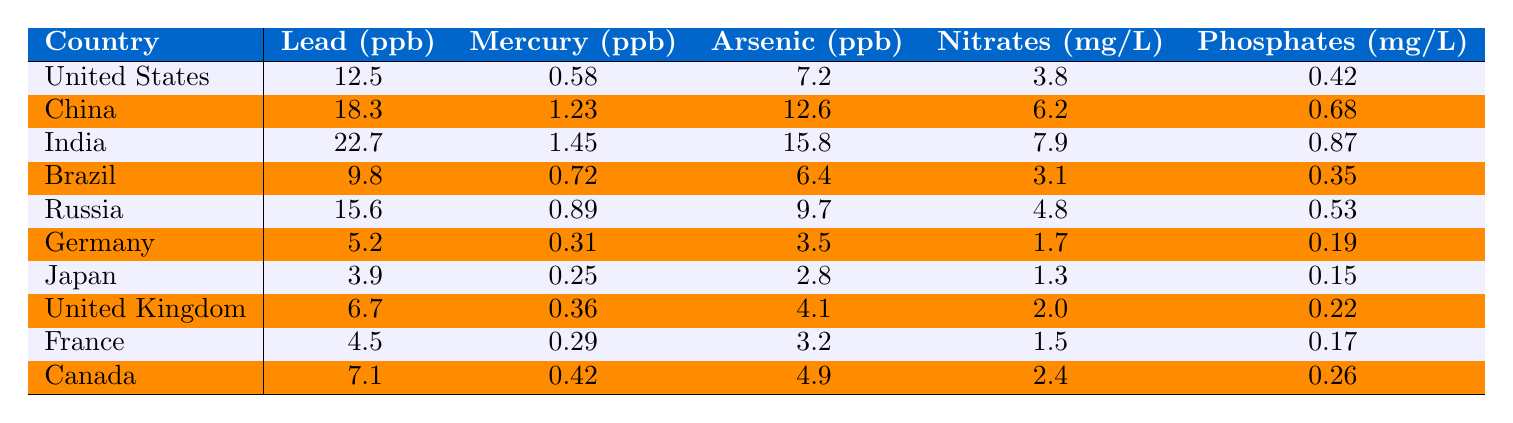What is the highest lead concentration reported in the table? The table lists the lead concentrations for each country, and the highest figure appears next to India, which shows a value of 22.7 ppb.
Answer: 22.7 ppb Which country has the lowest mercury concentration? By examining the mercury concentrations, Japan has the lowest value at 0.25 ppb.
Answer: 0.25 ppb Is the arsenic level in Germany higher than in Canada? Germany has an arsenic concentration of 3.5 ppb, while Canada shows a higher level of 4.9 ppb, so the statement is false.
Answer: No What is the average nitrates concentration across the first ten countries listed? Calculating the average involves summing the nitrates values of the first ten countries (3.8 + 6.2 + 7.9 + 3.1 + 4.8 + 1.7 + 1.3 + 2.0 + 1.5 + 2.4 = 34.7) and dividing by 10, resulting in an average of 3.47 mg/L.
Answer: 3.47 mg/L What is the difference in lead concentration between the country with the highest and lowest values? The highest lead concentration is 22.7 ppb (India) and the lowest is 2.1 ppb (Finland). The difference is calculated by subtracting the lowest from the highest: 22.7 - 2.1 = 20.6 ppb.
Answer: 20.6 ppb How many countries have mercury levels above 1.0 ppb? By checking the mercury values, 10 countries have concentrations above 1.0 ppb: China, India, Indonesia, South Africa, Nigeria, Argentina, Turkey, Saudi Arabia, Colombia, and Peru.
Answer: 10 countries Which country shows the highest level of phosphates? Upon reviewing the phosphates data, we see that India has the highest concentration with 0.87 mg/L.
Answer: 0.87 mg/L Are more countries listed with arsenic levels above 10 ppb than those below? The table reveals that 8 countries have arsenic levels above 10 ppb (India, China, Egypt, Nigeria, Argentina, Turkey, Bangladesh, Pakistan) while 42 countries have levels below. Therefore, the statement is false.
Answer: No What is the combined total of lead and mercury for the United States? The total for the United States is computed by adding the lead concentration (12.5 ppb) to the mercury concentration (0.58 ppb), resulting in a total of 13.08 ppb.
Answer: 13.08 ppb Which of the three pollutants (lead, mercury, or arsenic) has the highest maximum level recorded in the table? Comparing the maximum levels, lead reaches up to 22.7 ppb, mercury tops at 1.45 ppb, and arsenic peaks at 15.8 ppb. Thus, lead has the highest maximum at 22.7 ppb.
Answer: Lead at 22.7 ppb What percentage of the countries have phosphates levels greater than 0.5 mg/L? Only 18 out of the 50 countries have phosphates levels greater than 0.5 mg/L. The percentage is calculated as (18/50) * 100 = 36%.
Answer: 36% 